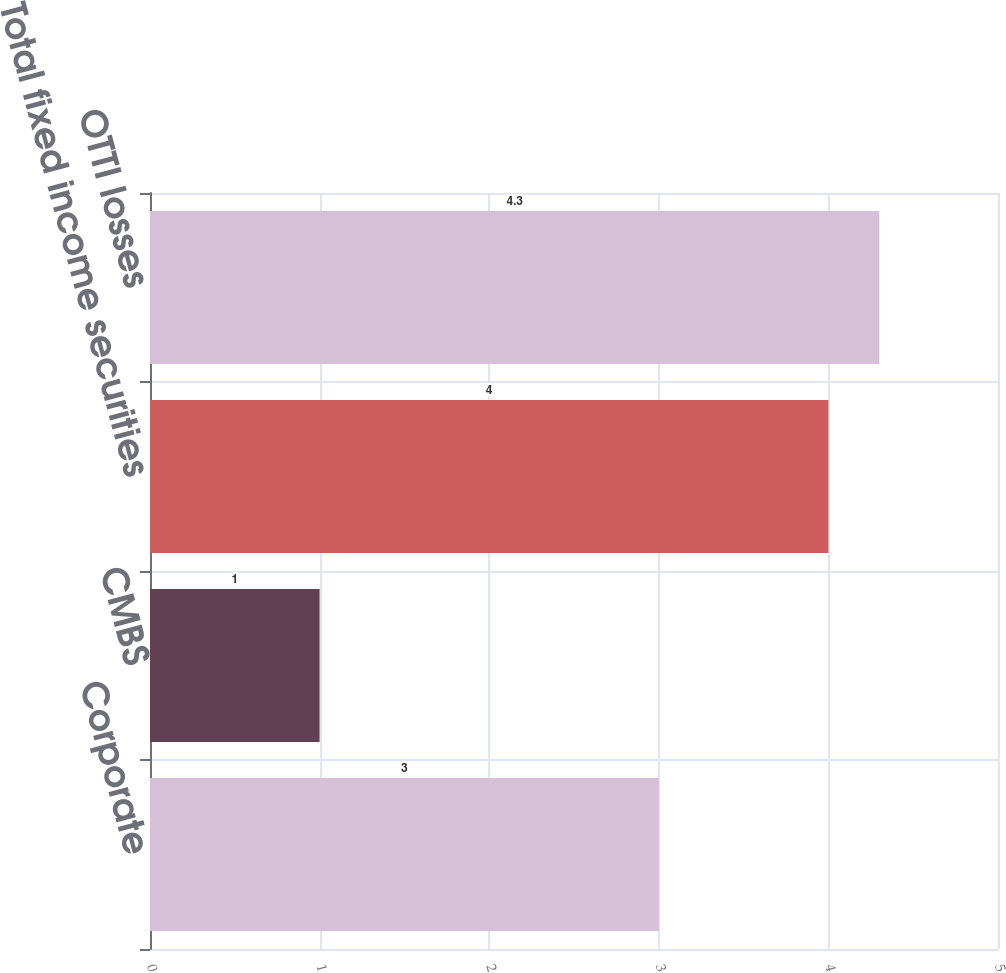Convert chart to OTSL. <chart><loc_0><loc_0><loc_500><loc_500><bar_chart><fcel>Corporate<fcel>CMBS<fcel>Total fixed income securities<fcel>OTTI losses<nl><fcel>3<fcel>1<fcel>4<fcel>4.3<nl></chart> 